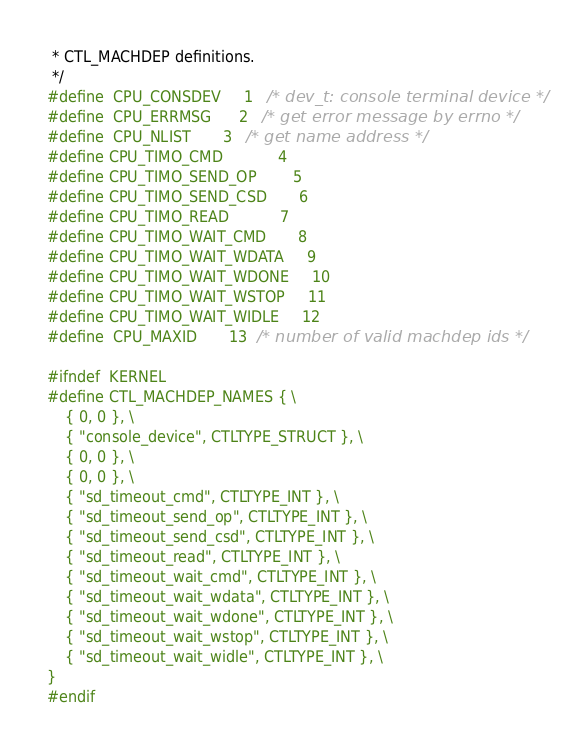Convert code to text. <code><loc_0><loc_0><loc_500><loc_500><_C_> * CTL_MACHDEP definitions.
 */
#define	CPU_CONSDEV		1	/* dev_t: console terminal device */
#define	CPU_ERRMSG		2	/* get error message by errno */
#define	CPU_NLIST		3	/* get name address */
#define CPU_TIMO_CMD            4
#define CPU_TIMO_SEND_OP        5
#define CPU_TIMO_SEND_CSD       6
#define CPU_TIMO_READ           7
#define CPU_TIMO_WAIT_CMD       8
#define CPU_TIMO_WAIT_WDATA     9
#define CPU_TIMO_WAIT_WDONE     10
#define CPU_TIMO_WAIT_WSTOP     11
#define CPU_TIMO_WAIT_WIDLE     12
#define	CPU_MAXID		13	/* number of valid machdep ids */

#ifndef	KERNEL
#define CTL_MACHDEP_NAMES { \
	{ 0, 0 }, \
	{ "console_device", CTLTYPE_STRUCT }, \
	{ 0, 0 }, \
	{ 0, 0 }, \
	{ "sd_timeout_cmd", CTLTYPE_INT }, \
	{ "sd_timeout_send_op", CTLTYPE_INT }, \
	{ "sd_timeout_send_csd", CTLTYPE_INT }, \
	{ "sd_timeout_read", CTLTYPE_INT }, \
	{ "sd_timeout_wait_cmd", CTLTYPE_INT }, \
	{ "sd_timeout_wait_wdata", CTLTYPE_INT }, \
	{ "sd_timeout_wait_wdone", CTLTYPE_INT }, \
	{ "sd_timeout_wait_wstop", CTLTYPE_INT }, \
	{ "sd_timeout_wait_widle", CTLTYPE_INT }, \
}
#endif
</code> 